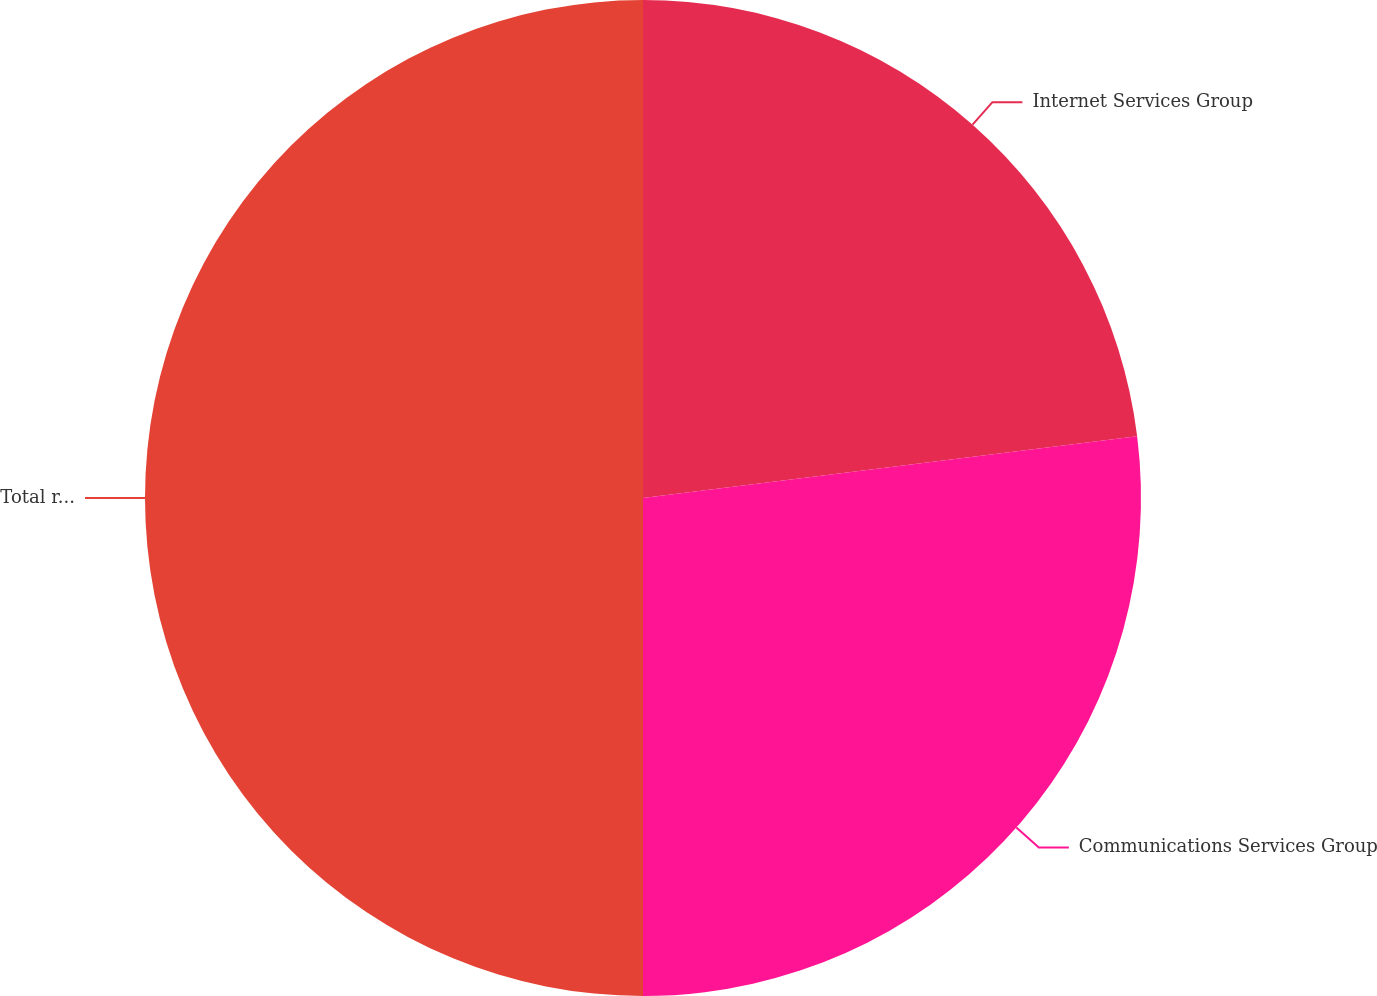Convert chart. <chart><loc_0><loc_0><loc_500><loc_500><pie_chart><fcel>Internet Services Group<fcel>Communications Services Group<fcel>Total revenues<nl><fcel>23.02%<fcel>26.98%<fcel>50.0%<nl></chart> 